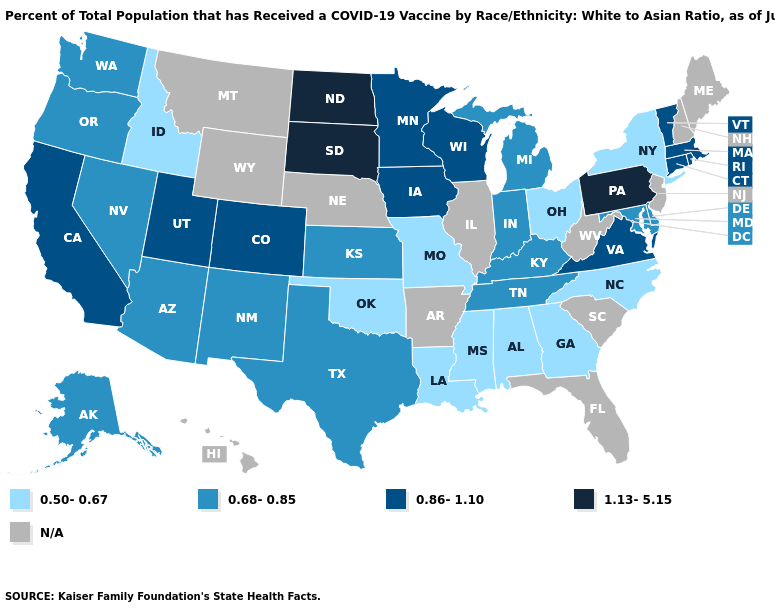Which states have the highest value in the USA?
Quick response, please. North Dakota, Pennsylvania, South Dakota. Does the map have missing data?
Short answer required. Yes. Name the states that have a value in the range 0.50-0.67?
Concise answer only. Alabama, Georgia, Idaho, Louisiana, Mississippi, Missouri, New York, North Carolina, Ohio, Oklahoma. Name the states that have a value in the range 1.13-5.15?
Give a very brief answer. North Dakota, Pennsylvania, South Dakota. What is the lowest value in the West?
Quick response, please. 0.50-0.67. What is the value of Wyoming?
Answer briefly. N/A. Among the states that border Iowa , which have the highest value?
Short answer required. South Dakota. What is the lowest value in states that border Illinois?
Write a very short answer. 0.50-0.67. Name the states that have a value in the range 0.68-0.85?
Quick response, please. Alaska, Arizona, Delaware, Indiana, Kansas, Kentucky, Maryland, Michigan, Nevada, New Mexico, Oregon, Tennessee, Texas, Washington. Name the states that have a value in the range 0.86-1.10?
Write a very short answer. California, Colorado, Connecticut, Iowa, Massachusetts, Minnesota, Rhode Island, Utah, Vermont, Virginia, Wisconsin. How many symbols are there in the legend?
Give a very brief answer. 5. What is the value of Vermont?
Answer briefly. 0.86-1.10. Name the states that have a value in the range 1.13-5.15?
Be succinct. North Dakota, Pennsylvania, South Dakota. What is the lowest value in the USA?
Answer briefly. 0.50-0.67. 